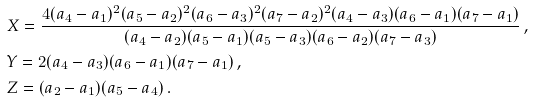Convert formula to latex. <formula><loc_0><loc_0><loc_500><loc_500>& X = \frac { 4 ( a _ { 4 } - a _ { 1 } ) ^ { 2 } ( a _ { 5 } - a _ { 2 } ) ^ { 2 } ( a _ { 6 } - a _ { 3 } ) ^ { 2 } ( a _ { 7 } - a _ { 2 } ) ^ { 2 } ( a _ { 4 } - a _ { 3 } ) ( a _ { 6 } - a _ { 1 } ) ( a _ { 7 } - a _ { 1 } ) } { ( a _ { 4 } - a _ { 2 } ) ( a _ { 5 } - a _ { 1 } ) ( a _ { 5 } - a _ { 3 } ) ( a _ { 6 } - a _ { 2 } ) ( a _ { 7 } - a _ { 3 } ) } \, , \\ & Y = 2 ( a _ { 4 } - a _ { 3 } ) ( a _ { 6 } - a _ { 1 } ) ( a _ { 7 } - a _ { 1 } ) \, , \\ & Z = ( a _ { 2 } - a _ { 1 } ) ( a _ { 5 } - a _ { 4 } ) \, .</formula> 